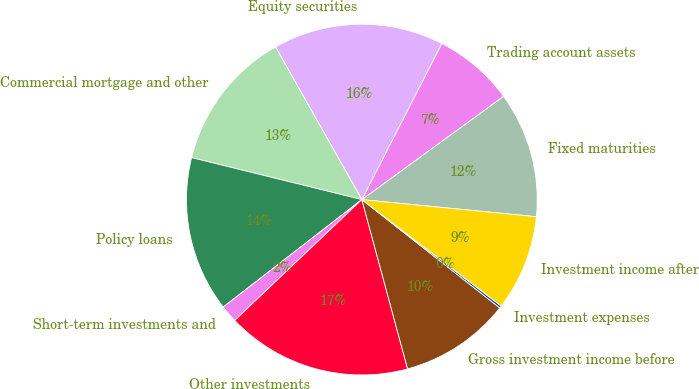<chart> <loc_0><loc_0><loc_500><loc_500><pie_chart><fcel>Fixed maturities<fcel>Trading account assets<fcel>Equity securities<fcel>Commercial mortgage and other<fcel>Policy loans<fcel>Short-term investments and<fcel>Other investments<fcel>Gross investment income before<fcel>Investment expenses<fcel>Investment income after<nl><fcel>11.58%<fcel>7.44%<fcel>15.72%<fcel>12.96%<fcel>14.34%<fcel>1.6%<fcel>17.1%<fcel>10.2%<fcel>0.22%<fcel>8.82%<nl></chart> 